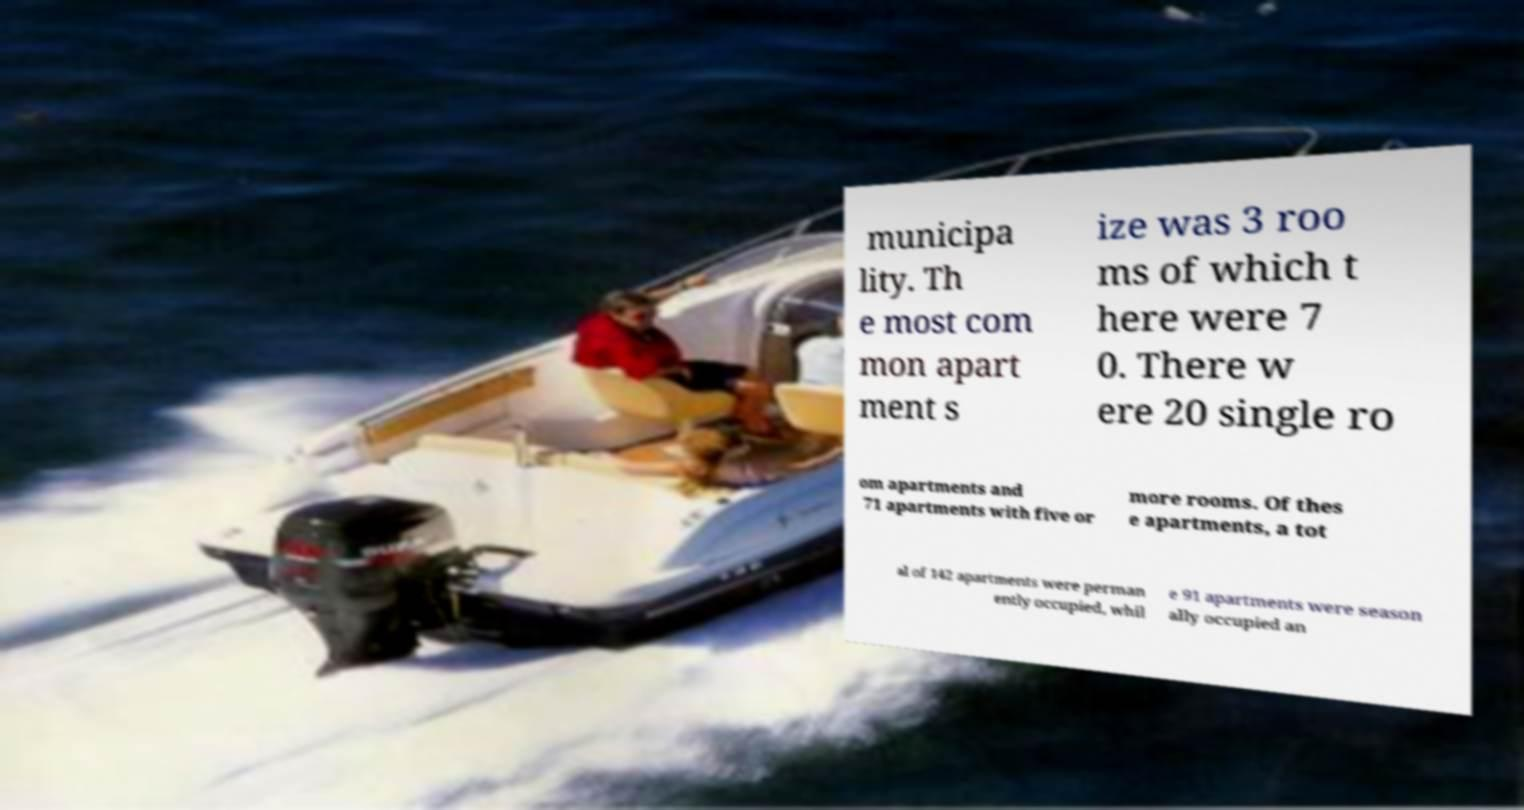I need the written content from this picture converted into text. Can you do that? municipa lity. Th e most com mon apart ment s ize was 3 roo ms of which t here were 7 0. There w ere 20 single ro om apartments and 71 apartments with five or more rooms. Of thes e apartments, a tot al of 142 apartments were perman ently occupied, whil e 91 apartments were season ally occupied an 